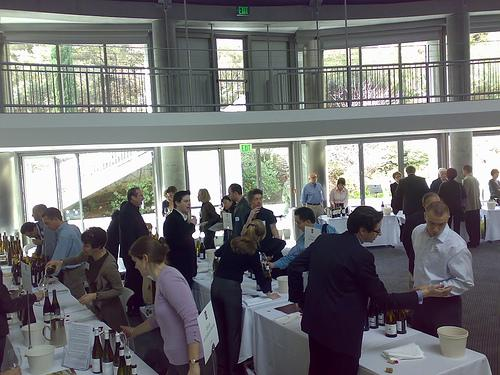What is on the table to the left? wine 